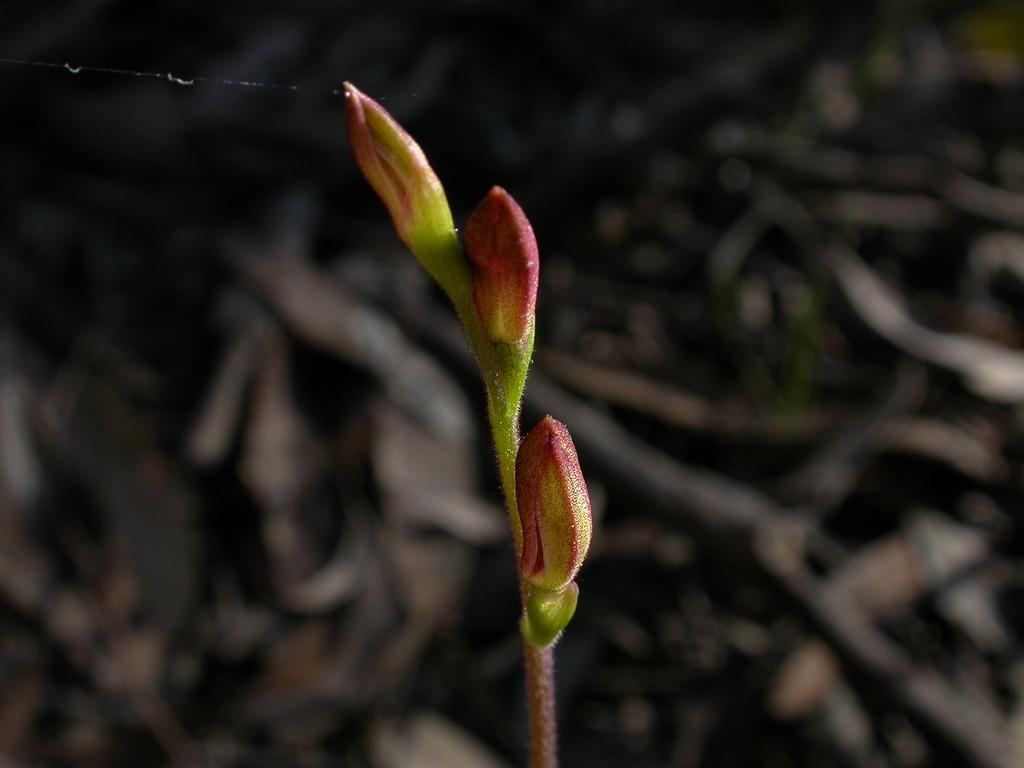What is present in the image? There is a plant in the image. What specific feature of the plant can be observed? The plant has three flower buds. What is the color of the flower buds? The flower buds are pink in color. Are there any other colors visible on the flower buds? Yes, the flower buds have a green color shade. What can be seen in the background of the image? There are dried twigs in the background of the image. How many toads are sitting on the flower buds in the image? There are no toads present in the image; it only features a plant with flower buds and dried twigs in the background. Can you tell me the name of the parent of the plant in the image? There is no information about the parent of the plant in the image, as it only shows the plant itself and its flower buds. 